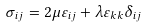Convert formula to latex. <formula><loc_0><loc_0><loc_500><loc_500>\, \sigma _ { i j } = 2 \mu \varepsilon _ { i j } + \lambda \varepsilon _ { k k } \delta _ { i j }</formula> 